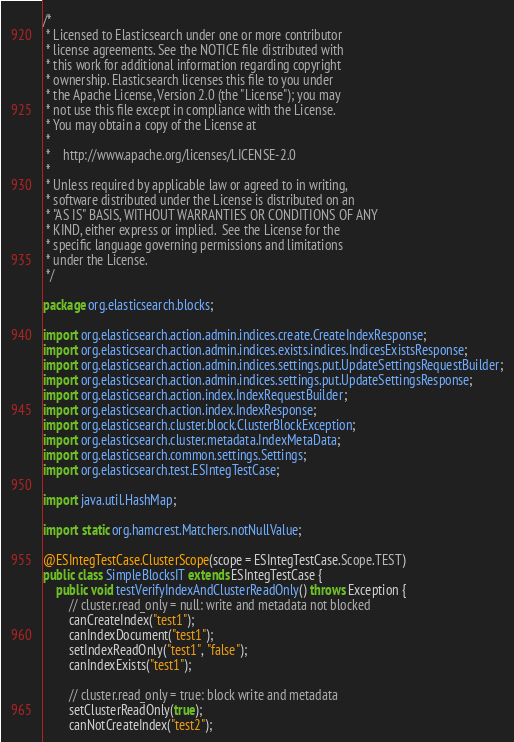<code> <loc_0><loc_0><loc_500><loc_500><_Java_>/*
 * Licensed to Elasticsearch under one or more contributor
 * license agreements. See the NOTICE file distributed with
 * this work for additional information regarding copyright
 * ownership. Elasticsearch licenses this file to you under
 * the Apache License, Version 2.0 (the "License"); you may
 * not use this file except in compliance with the License.
 * You may obtain a copy of the License at
 *
 *    http://www.apache.org/licenses/LICENSE-2.0
 *
 * Unless required by applicable law or agreed to in writing,
 * software distributed under the License is distributed on an
 * "AS IS" BASIS, WITHOUT WARRANTIES OR CONDITIONS OF ANY
 * KIND, either express or implied.  See the License for the
 * specific language governing permissions and limitations
 * under the License.
 */

package org.elasticsearch.blocks;

import org.elasticsearch.action.admin.indices.create.CreateIndexResponse;
import org.elasticsearch.action.admin.indices.exists.indices.IndicesExistsResponse;
import org.elasticsearch.action.admin.indices.settings.put.UpdateSettingsRequestBuilder;
import org.elasticsearch.action.admin.indices.settings.put.UpdateSettingsResponse;
import org.elasticsearch.action.index.IndexRequestBuilder;
import org.elasticsearch.action.index.IndexResponse;
import org.elasticsearch.cluster.block.ClusterBlockException;
import org.elasticsearch.cluster.metadata.IndexMetaData;
import org.elasticsearch.common.settings.Settings;
import org.elasticsearch.test.ESIntegTestCase;

import java.util.HashMap;

import static org.hamcrest.Matchers.notNullValue;

@ESIntegTestCase.ClusterScope(scope = ESIntegTestCase.Scope.TEST)
public class SimpleBlocksIT extends ESIntegTestCase {
    public void testVerifyIndexAndClusterReadOnly() throws Exception {
        // cluster.read_only = null: write and metadata not blocked
        canCreateIndex("test1");
        canIndexDocument("test1");
        setIndexReadOnly("test1", "false");
        canIndexExists("test1");

        // cluster.read_only = true: block write and metadata
        setClusterReadOnly(true);
        canNotCreateIndex("test2");</code> 